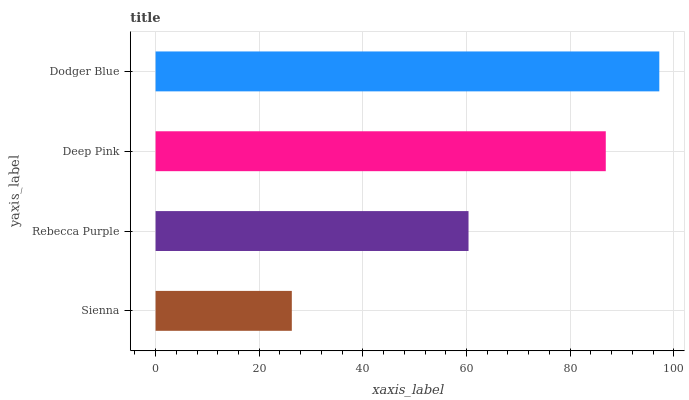Is Sienna the minimum?
Answer yes or no. Yes. Is Dodger Blue the maximum?
Answer yes or no. Yes. Is Rebecca Purple the minimum?
Answer yes or no. No. Is Rebecca Purple the maximum?
Answer yes or no. No. Is Rebecca Purple greater than Sienna?
Answer yes or no. Yes. Is Sienna less than Rebecca Purple?
Answer yes or no. Yes. Is Sienna greater than Rebecca Purple?
Answer yes or no. No. Is Rebecca Purple less than Sienna?
Answer yes or no. No. Is Deep Pink the high median?
Answer yes or no. Yes. Is Rebecca Purple the low median?
Answer yes or no. Yes. Is Rebecca Purple the high median?
Answer yes or no. No. Is Sienna the low median?
Answer yes or no. No. 